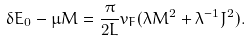Convert formula to latex. <formula><loc_0><loc_0><loc_500><loc_500>\delta E _ { 0 } - \mu M = \frac { \pi } { 2 L } v _ { F } ( \lambda M ^ { 2 } + \lambda ^ { - 1 } J ^ { 2 } ) .</formula> 